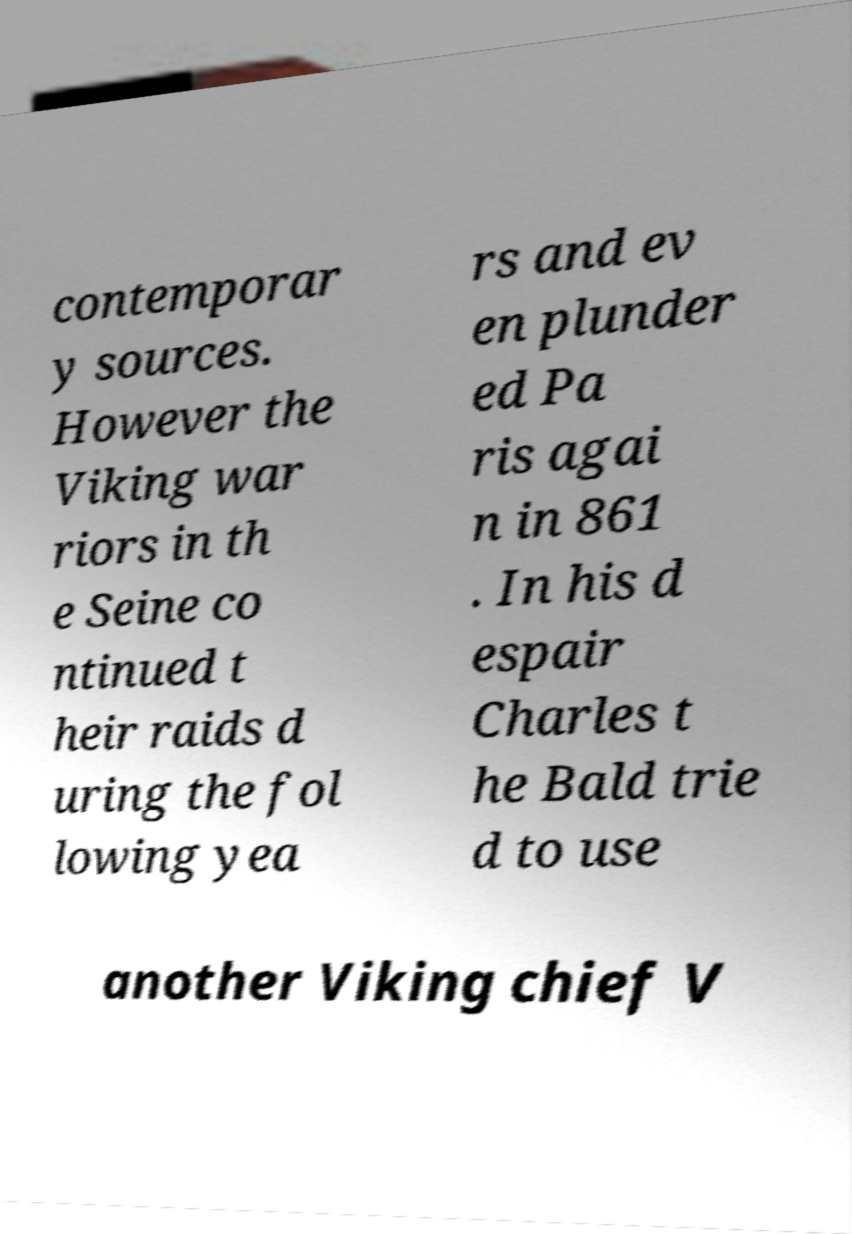Please read and relay the text visible in this image. What does it say? contemporar y sources. However the Viking war riors in th e Seine co ntinued t heir raids d uring the fol lowing yea rs and ev en plunder ed Pa ris agai n in 861 . In his d espair Charles t he Bald trie d to use another Viking chief V 